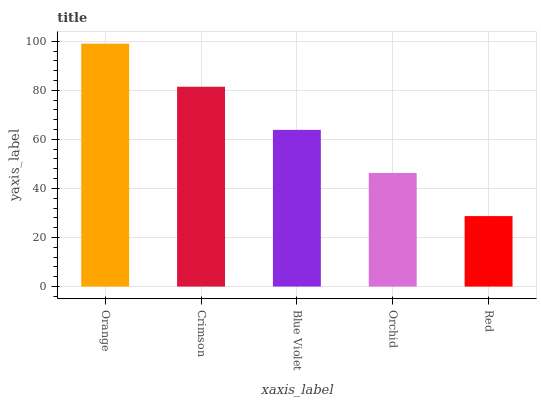Is Crimson the minimum?
Answer yes or no. No. Is Crimson the maximum?
Answer yes or no. No. Is Orange greater than Crimson?
Answer yes or no. Yes. Is Crimson less than Orange?
Answer yes or no. Yes. Is Crimson greater than Orange?
Answer yes or no. No. Is Orange less than Crimson?
Answer yes or no. No. Is Blue Violet the high median?
Answer yes or no. Yes. Is Blue Violet the low median?
Answer yes or no. Yes. Is Orange the high median?
Answer yes or no. No. Is Red the low median?
Answer yes or no. No. 